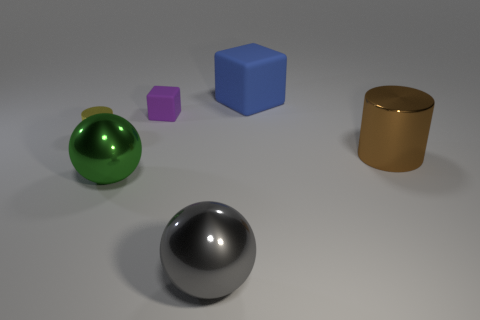Which object appears to be the largest? Based on the image, the blue cube seems to be the largest object in comparison to the others present. 